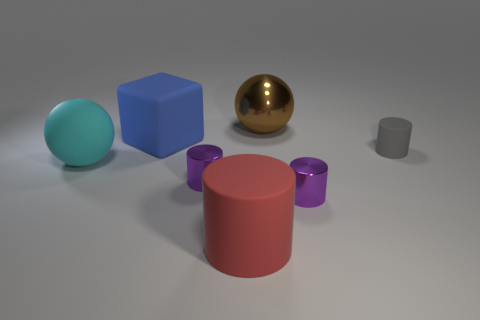Add 1 gray objects. How many objects exist? 8 Subtract all cubes. How many objects are left? 6 Add 5 cyan rubber balls. How many cyan rubber balls are left? 6 Add 7 small purple metal cylinders. How many small purple metal cylinders exist? 9 Subtract 0 red cubes. How many objects are left? 7 Subtract all matte balls. Subtract all small purple metallic cylinders. How many objects are left? 4 